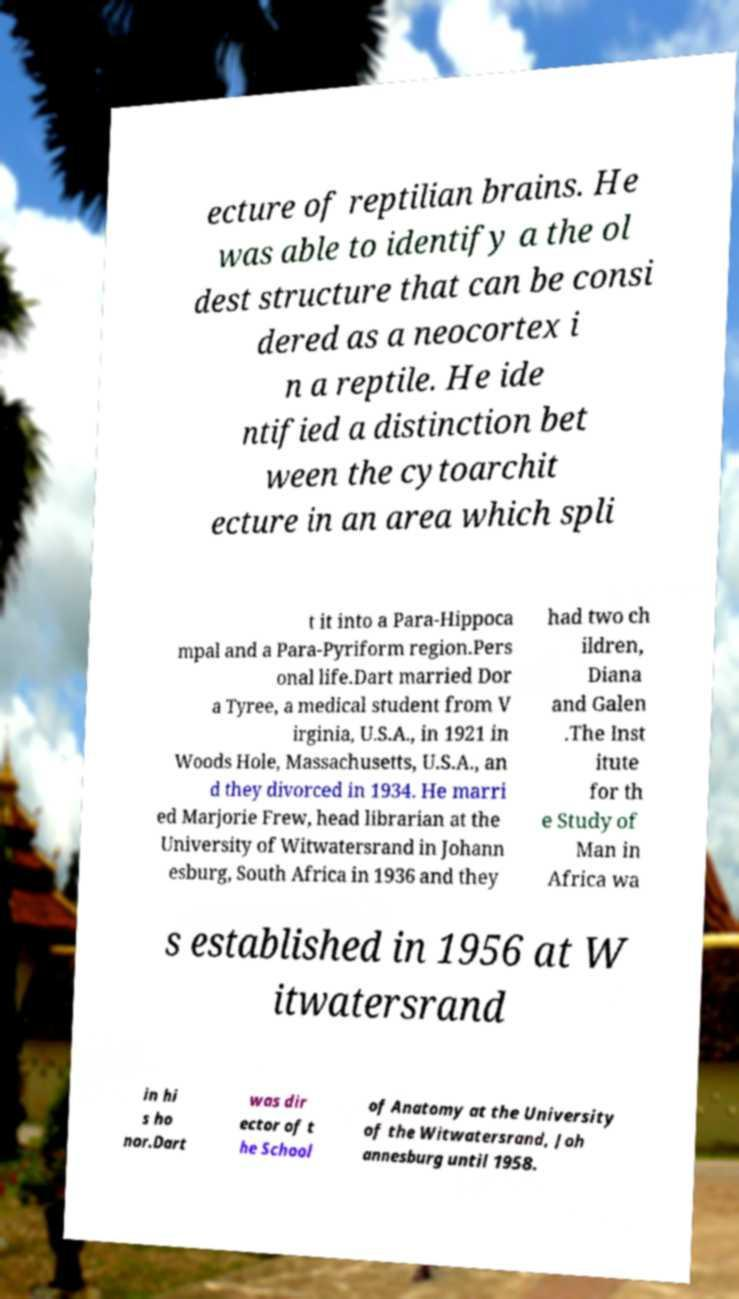Can you read and provide the text displayed in the image?This photo seems to have some interesting text. Can you extract and type it out for me? ecture of reptilian brains. He was able to identify a the ol dest structure that can be consi dered as a neocortex i n a reptile. He ide ntified a distinction bet ween the cytoarchit ecture in an area which spli t it into a Para-Hippoca mpal and a Para-Pyriform region.Pers onal life.Dart married Dor a Tyree, a medical student from V irginia, U.S.A., in 1921 in Woods Hole, Massachusetts, U.S.A., an d they divorced in 1934. He marri ed Marjorie Frew, head librarian at the University of Witwatersrand in Johann esburg, South Africa in 1936 and they had two ch ildren, Diana and Galen .The Inst itute for th e Study of Man in Africa wa s established in 1956 at W itwatersrand in hi s ho nor.Dart was dir ector of t he School of Anatomy at the University of the Witwatersrand, Joh annesburg until 1958. 